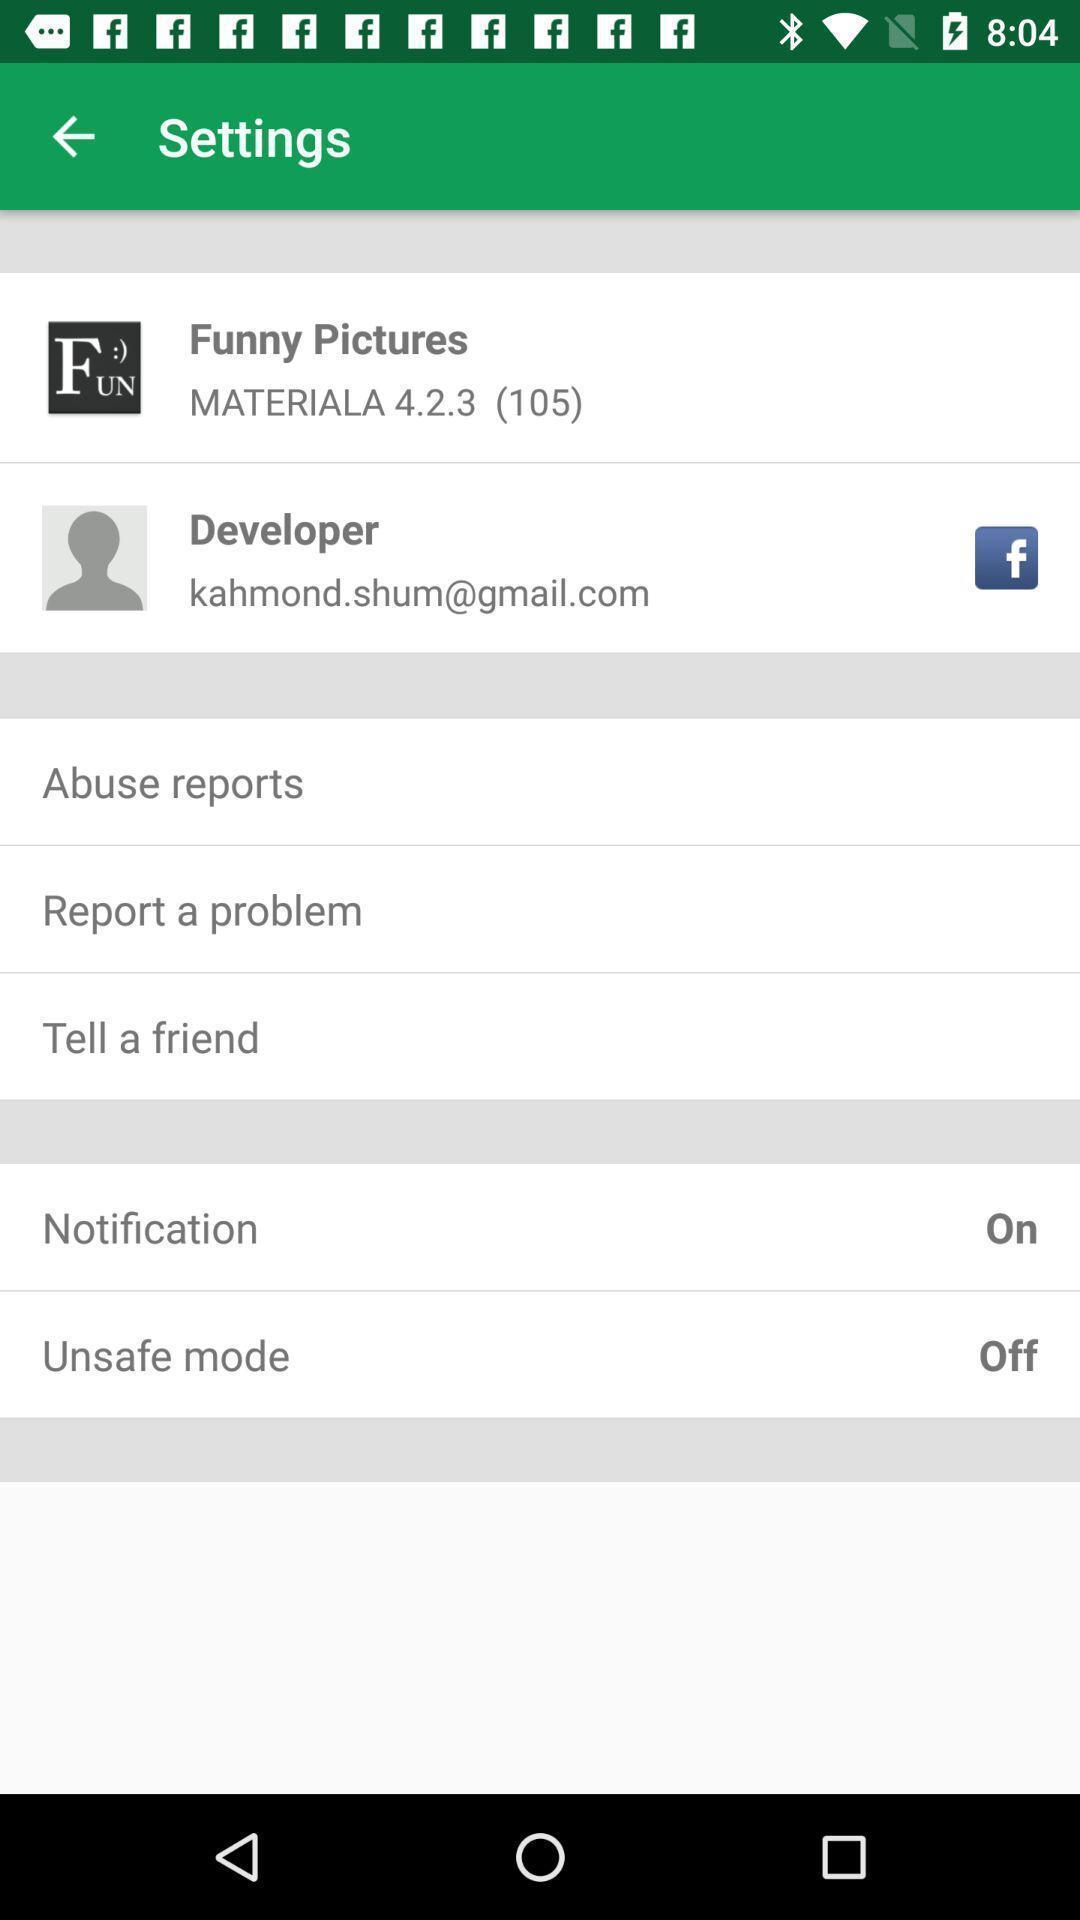Explain the elements present in this screenshot. Settings page displaying various options. 